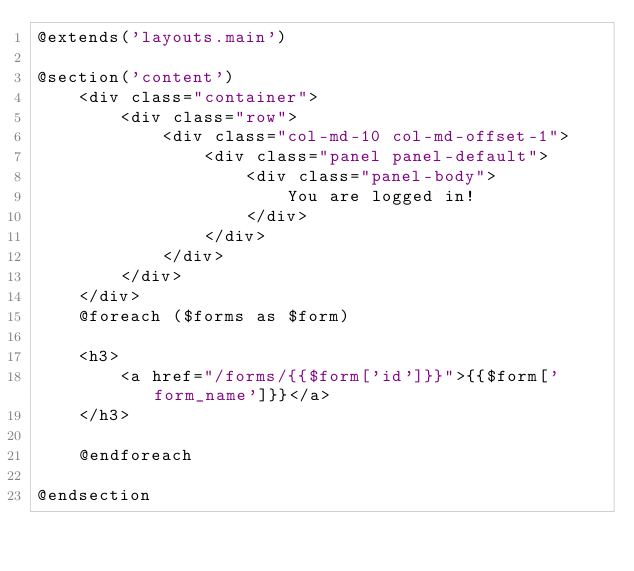Convert code to text. <code><loc_0><loc_0><loc_500><loc_500><_PHP_>@extends('layouts.main')

@section('content')
    <div class="container">
        <div class="row">
            <div class="col-md-10 col-md-offset-1">
                <div class="panel panel-default">
                    <div class="panel-body">
                        You are logged in!
                    </div>
                </div>
            </div>
        </div>
    </div>
    @foreach ($forms as $form)

    <h3>
        <a href="/forms/{{$form['id']}}">{{$form['form_name']}}</a>
    </h3>

    @endforeach

@endsection
</code> 